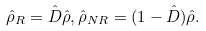Convert formula to latex. <formula><loc_0><loc_0><loc_500><loc_500>\hat { \rho } _ { R } = \hat { D } \hat { \rho } , \hat { \rho } _ { N R } = ( 1 - \hat { D } ) \hat { \rho } .</formula> 